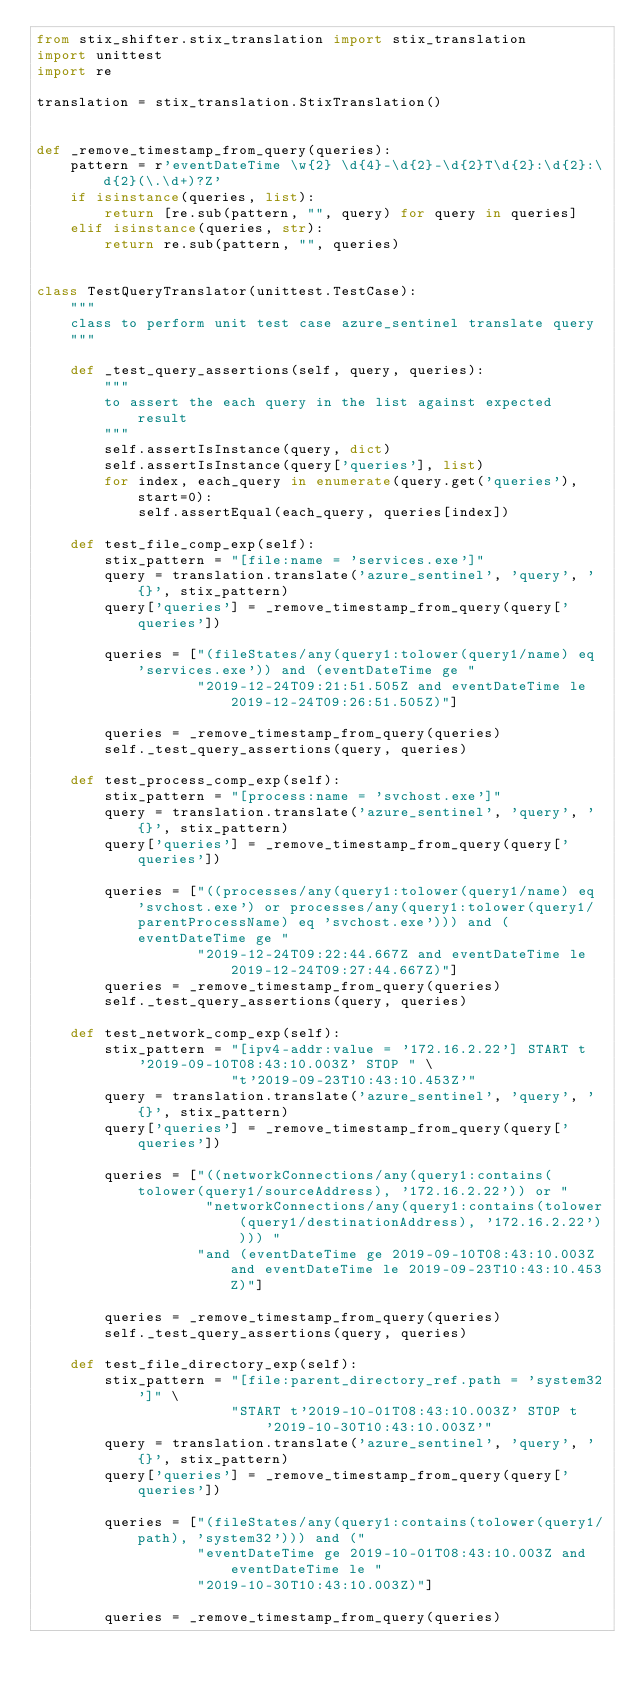<code> <loc_0><loc_0><loc_500><loc_500><_Python_>from stix_shifter.stix_translation import stix_translation
import unittest
import re

translation = stix_translation.StixTranslation()


def _remove_timestamp_from_query(queries):
    pattern = r'eventDateTime \w{2} \d{4}-\d{2}-\d{2}T\d{2}:\d{2}:\d{2}(\.\d+)?Z'
    if isinstance(queries, list):
        return [re.sub(pattern, "", query) for query in queries]
    elif isinstance(queries, str):
        return re.sub(pattern, "", queries)


class TestQueryTranslator(unittest.TestCase):
    """
    class to perform unit test case azure_sentinel translate query
    """

    def _test_query_assertions(self, query, queries):
        """
        to assert the each query in the list against expected result
        """
        self.assertIsInstance(query, dict)
        self.assertIsInstance(query['queries'], list)
        for index, each_query in enumerate(query.get('queries'), start=0):
            self.assertEqual(each_query, queries[index])

    def test_file_comp_exp(self):
        stix_pattern = "[file:name = 'services.exe']"
        query = translation.translate('azure_sentinel', 'query', '{}', stix_pattern)
        query['queries'] = _remove_timestamp_from_query(query['queries'])

        queries = ["(fileStates/any(query1:tolower(query1/name) eq 'services.exe')) and (eventDateTime ge "
                   "2019-12-24T09:21:51.505Z and eventDateTime le 2019-12-24T09:26:51.505Z)"]

        queries = _remove_timestamp_from_query(queries)
        self._test_query_assertions(query, queries)

    def test_process_comp_exp(self):
        stix_pattern = "[process:name = 'svchost.exe']"
        query = translation.translate('azure_sentinel', 'query', '{}', stix_pattern)
        query['queries'] = _remove_timestamp_from_query(query['queries'])

        queries = ["((processes/any(query1:tolower(query1/name) eq 'svchost.exe') or processes/any(query1:tolower(query1/parentProcessName) eq 'svchost.exe'))) and (eventDateTime ge "
                   "2019-12-24T09:22:44.667Z and eventDateTime le 2019-12-24T09:27:44.667Z)"]
        queries = _remove_timestamp_from_query(queries)
        self._test_query_assertions(query, queries)

    def test_network_comp_exp(self):
        stix_pattern = "[ipv4-addr:value = '172.16.2.22'] START t'2019-09-10T08:43:10.003Z' STOP " \
                       "t'2019-09-23T10:43:10.453Z'"
        query = translation.translate('azure_sentinel', 'query', '{}', stix_pattern)
        query['queries'] = _remove_timestamp_from_query(query['queries'])

        queries = ["((networkConnections/any(query1:contains(tolower(query1/sourceAddress), '172.16.2.22')) or "
                    "networkConnections/any(query1:contains(tolower(query1/destinationAddress), '172.16.2.22')))) "
                   "and (eventDateTime ge 2019-09-10T08:43:10.003Z and eventDateTime le 2019-09-23T10:43:10.453Z)"]

        queries = _remove_timestamp_from_query(queries)
        self._test_query_assertions(query, queries)

    def test_file_directory_exp(self):
        stix_pattern = "[file:parent_directory_ref.path = 'system32']" \
                       "START t'2019-10-01T08:43:10.003Z' STOP t'2019-10-30T10:43:10.003Z'"
        query = translation.translate('azure_sentinel', 'query', '{}', stix_pattern)
        query['queries'] = _remove_timestamp_from_query(query['queries'])

        queries = ["(fileStates/any(query1:contains(tolower(query1/path), 'system32'))) and ("
                   "eventDateTime ge 2019-10-01T08:43:10.003Z and eventDateTime le "
                   "2019-10-30T10:43:10.003Z)"]

        queries = _remove_timestamp_from_query(queries)</code> 